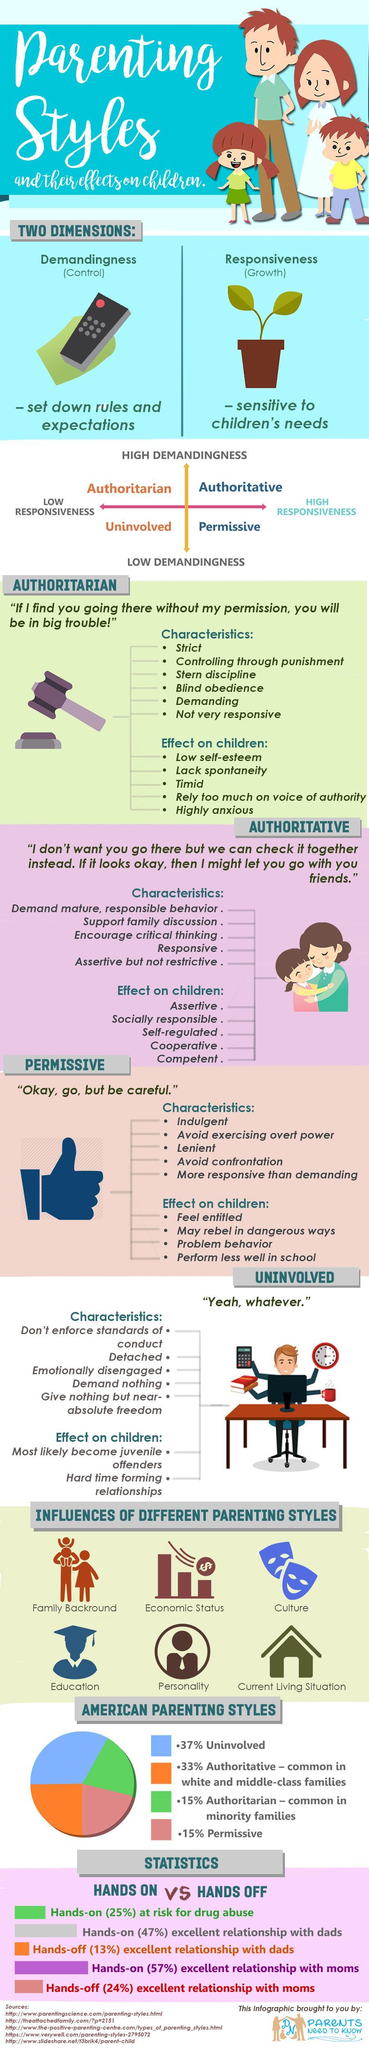Which type of parenting makes children qualified and supportive?
Answer the question with a short phrase. Authoritative What is the cause and effect of "Authoritative" parenting? High Demandingness, High Responsiveness What is the cause and effect of "Permissive" parenting? Low Demandingness, High Responsiveness Which kind of parenting is second-most common in America? Authoritative What is the color code given to "Authoritarian" in the pie graph- orange, blue, green, red? green Which type of parenting makes children not good in studies? Permissive What is the color code given to "Uninvolved" in the pie graph- orange, blue, red, green? blue What is the cause and effect of  "Authoritarian" parenting? High Demandingness, low responsiveness What is the fifth factor that affects parenting style? Personality What is the cause and effect of "Uninvolved" parenting? low responsiveness, Low Demandingness 